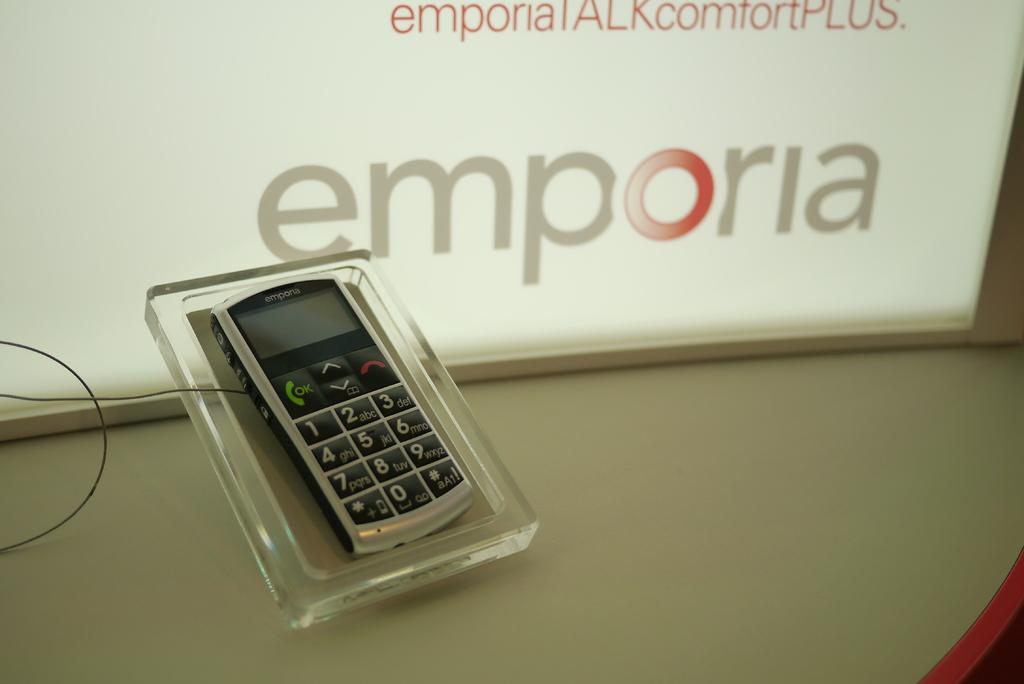<image>
Describe the image concisely. emporia phone sits a display on the counter at store 